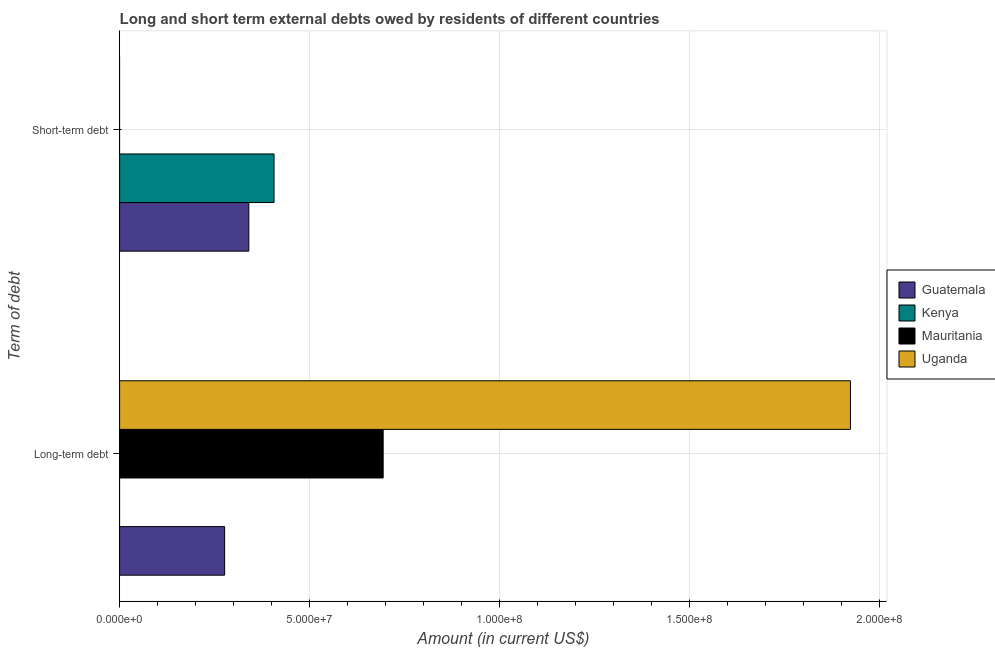How many groups of bars are there?
Provide a short and direct response. 2. Are the number of bars on each tick of the Y-axis equal?
Your answer should be compact. No. What is the label of the 2nd group of bars from the top?
Your response must be concise. Long-term debt. What is the long-term debts owed by residents in Uganda?
Give a very brief answer. 1.92e+08. Across all countries, what is the maximum long-term debts owed by residents?
Provide a short and direct response. 1.92e+08. Across all countries, what is the minimum long-term debts owed by residents?
Make the answer very short. 0. In which country was the short-term debts owed by residents maximum?
Give a very brief answer. Kenya. What is the total short-term debts owed by residents in the graph?
Offer a terse response. 7.46e+07. What is the difference between the long-term debts owed by residents in Uganda and that in Guatemala?
Your response must be concise. 1.65e+08. What is the difference between the short-term debts owed by residents in Kenya and the long-term debts owed by residents in Guatemala?
Provide a short and direct response. 1.30e+07. What is the average short-term debts owed by residents per country?
Offer a very short reply. 1.87e+07. What is the difference between the short-term debts owed by residents and long-term debts owed by residents in Guatemala?
Your answer should be very brief. 6.36e+06. In how many countries, is the short-term debts owed by residents greater than 40000000 US$?
Ensure brevity in your answer.  1. What is the ratio of the long-term debts owed by residents in Mauritania to that in Uganda?
Offer a very short reply. 0.36. In how many countries, is the long-term debts owed by residents greater than the average long-term debts owed by residents taken over all countries?
Your answer should be very brief. 1. How many bars are there?
Your answer should be very brief. 5. Are the values on the major ticks of X-axis written in scientific E-notation?
Give a very brief answer. Yes. How many legend labels are there?
Offer a very short reply. 4. What is the title of the graph?
Give a very brief answer. Long and short term external debts owed by residents of different countries. What is the label or title of the X-axis?
Offer a very short reply. Amount (in current US$). What is the label or title of the Y-axis?
Give a very brief answer. Term of debt. What is the Amount (in current US$) in Guatemala in Long-term debt?
Provide a short and direct response. 2.76e+07. What is the Amount (in current US$) of Mauritania in Long-term debt?
Your answer should be compact. 6.94e+07. What is the Amount (in current US$) in Uganda in Long-term debt?
Offer a very short reply. 1.92e+08. What is the Amount (in current US$) in Guatemala in Short-term debt?
Make the answer very short. 3.40e+07. What is the Amount (in current US$) of Kenya in Short-term debt?
Make the answer very short. 4.06e+07. Across all Term of debt, what is the maximum Amount (in current US$) of Guatemala?
Your answer should be very brief. 3.40e+07. Across all Term of debt, what is the maximum Amount (in current US$) of Kenya?
Your answer should be very brief. 4.06e+07. Across all Term of debt, what is the maximum Amount (in current US$) in Mauritania?
Provide a short and direct response. 6.94e+07. Across all Term of debt, what is the maximum Amount (in current US$) of Uganda?
Provide a short and direct response. 1.92e+08. Across all Term of debt, what is the minimum Amount (in current US$) of Guatemala?
Make the answer very short. 2.76e+07. Across all Term of debt, what is the minimum Amount (in current US$) of Mauritania?
Provide a short and direct response. 0. Across all Term of debt, what is the minimum Amount (in current US$) of Uganda?
Ensure brevity in your answer.  0. What is the total Amount (in current US$) in Guatemala in the graph?
Provide a succinct answer. 6.16e+07. What is the total Amount (in current US$) in Kenya in the graph?
Your answer should be compact. 4.06e+07. What is the total Amount (in current US$) in Mauritania in the graph?
Provide a succinct answer. 6.94e+07. What is the total Amount (in current US$) in Uganda in the graph?
Offer a terse response. 1.92e+08. What is the difference between the Amount (in current US$) of Guatemala in Long-term debt and that in Short-term debt?
Your answer should be compact. -6.36e+06. What is the difference between the Amount (in current US$) of Guatemala in Long-term debt and the Amount (in current US$) of Kenya in Short-term debt?
Offer a very short reply. -1.30e+07. What is the average Amount (in current US$) of Guatemala per Term of debt?
Your answer should be very brief. 3.08e+07. What is the average Amount (in current US$) of Kenya per Term of debt?
Give a very brief answer. 2.03e+07. What is the average Amount (in current US$) of Mauritania per Term of debt?
Offer a very short reply. 3.47e+07. What is the average Amount (in current US$) of Uganda per Term of debt?
Keep it short and to the point. 9.62e+07. What is the difference between the Amount (in current US$) of Guatemala and Amount (in current US$) of Mauritania in Long-term debt?
Ensure brevity in your answer.  -4.17e+07. What is the difference between the Amount (in current US$) in Guatemala and Amount (in current US$) in Uganda in Long-term debt?
Ensure brevity in your answer.  -1.65e+08. What is the difference between the Amount (in current US$) of Mauritania and Amount (in current US$) of Uganda in Long-term debt?
Keep it short and to the point. -1.23e+08. What is the difference between the Amount (in current US$) in Guatemala and Amount (in current US$) in Kenya in Short-term debt?
Keep it short and to the point. -6.64e+06. What is the ratio of the Amount (in current US$) in Guatemala in Long-term debt to that in Short-term debt?
Offer a very short reply. 0.81. What is the difference between the highest and the second highest Amount (in current US$) of Guatemala?
Offer a terse response. 6.36e+06. What is the difference between the highest and the lowest Amount (in current US$) of Guatemala?
Provide a short and direct response. 6.36e+06. What is the difference between the highest and the lowest Amount (in current US$) of Kenya?
Ensure brevity in your answer.  4.06e+07. What is the difference between the highest and the lowest Amount (in current US$) in Mauritania?
Offer a very short reply. 6.94e+07. What is the difference between the highest and the lowest Amount (in current US$) in Uganda?
Your answer should be compact. 1.92e+08. 